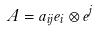<formula> <loc_0><loc_0><loc_500><loc_500>A = a _ { i j } e _ { i } \otimes e ^ { j }</formula> 